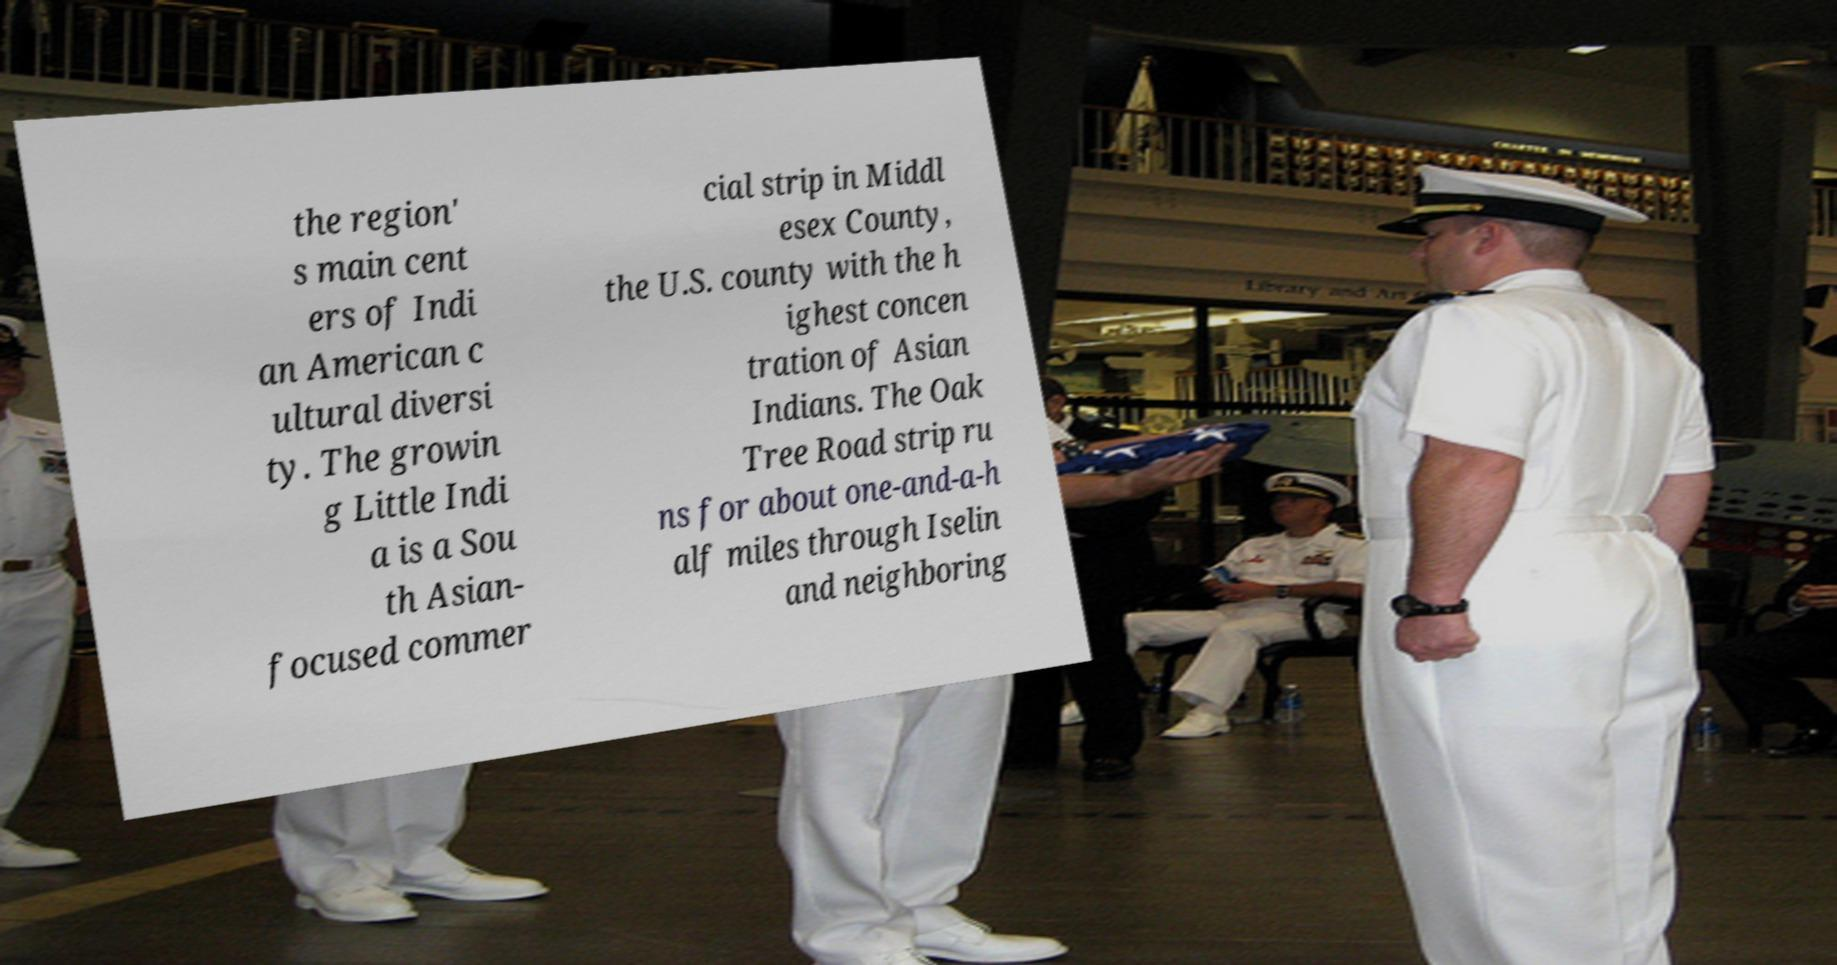Could you extract and type out the text from this image? the region' s main cent ers of Indi an American c ultural diversi ty. The growin g Little Indi a is a Sou th Asian- focused commer cial strip in Middl esex County, the U.S. county with the h ighest concen tration of Asian Indians. The Oak Tree Road strip ru ns for about one-and-a-h alf miles through Iselin and neighboring 